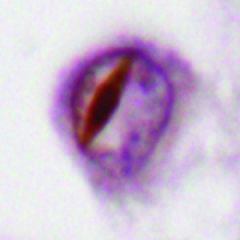what are associated with neuronal intranuclear inclusions containing tdp43?
Answer the question using a single word or phrase. Some forms of ftld 